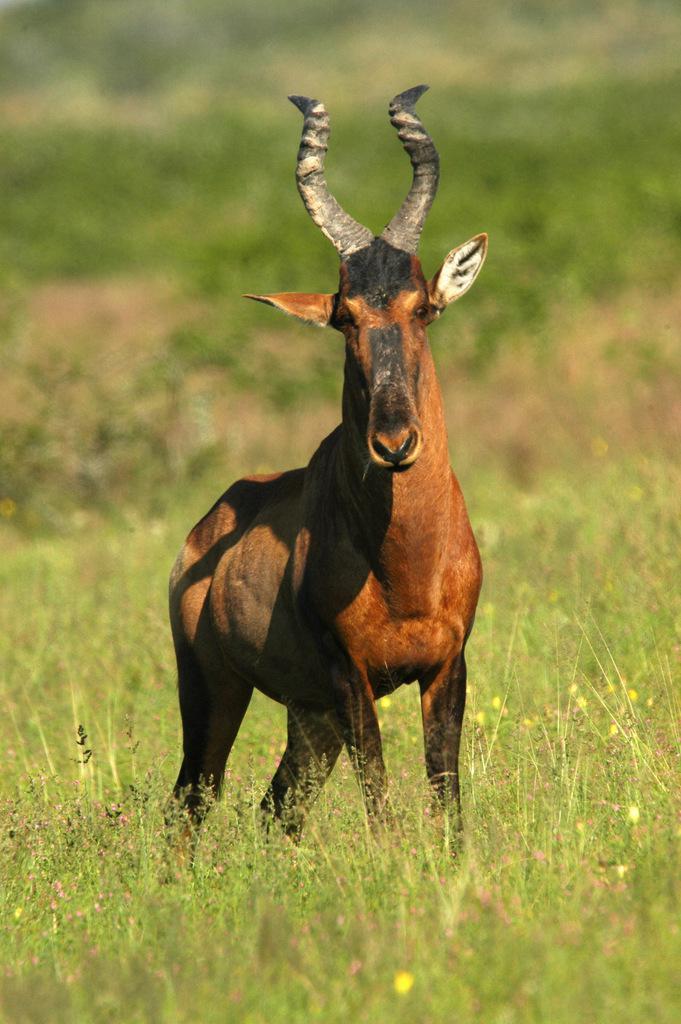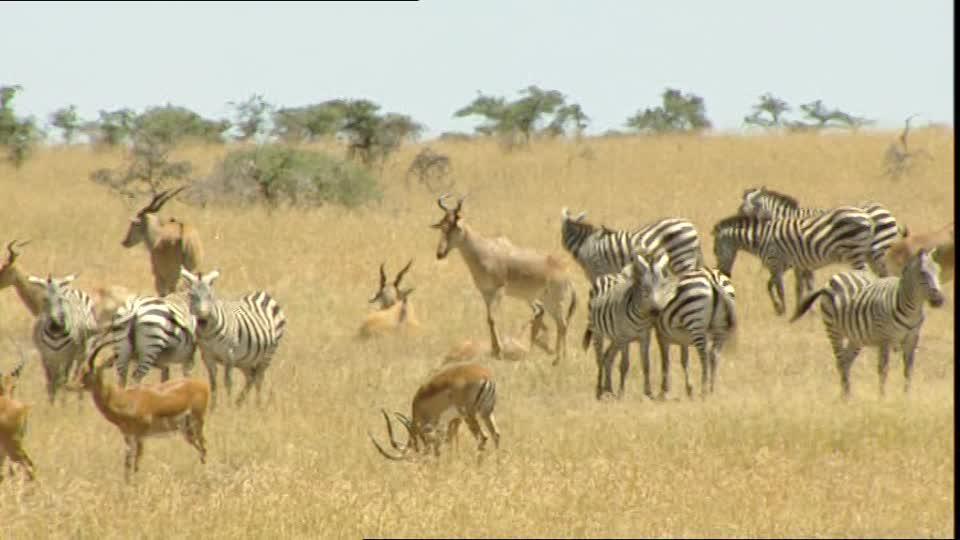The first image is the image on the left, the second image is the image on the right. Considering the images on both sides, is "There are two different types of animals in one of the pictures." valid? Answer yes or no. Yes. 